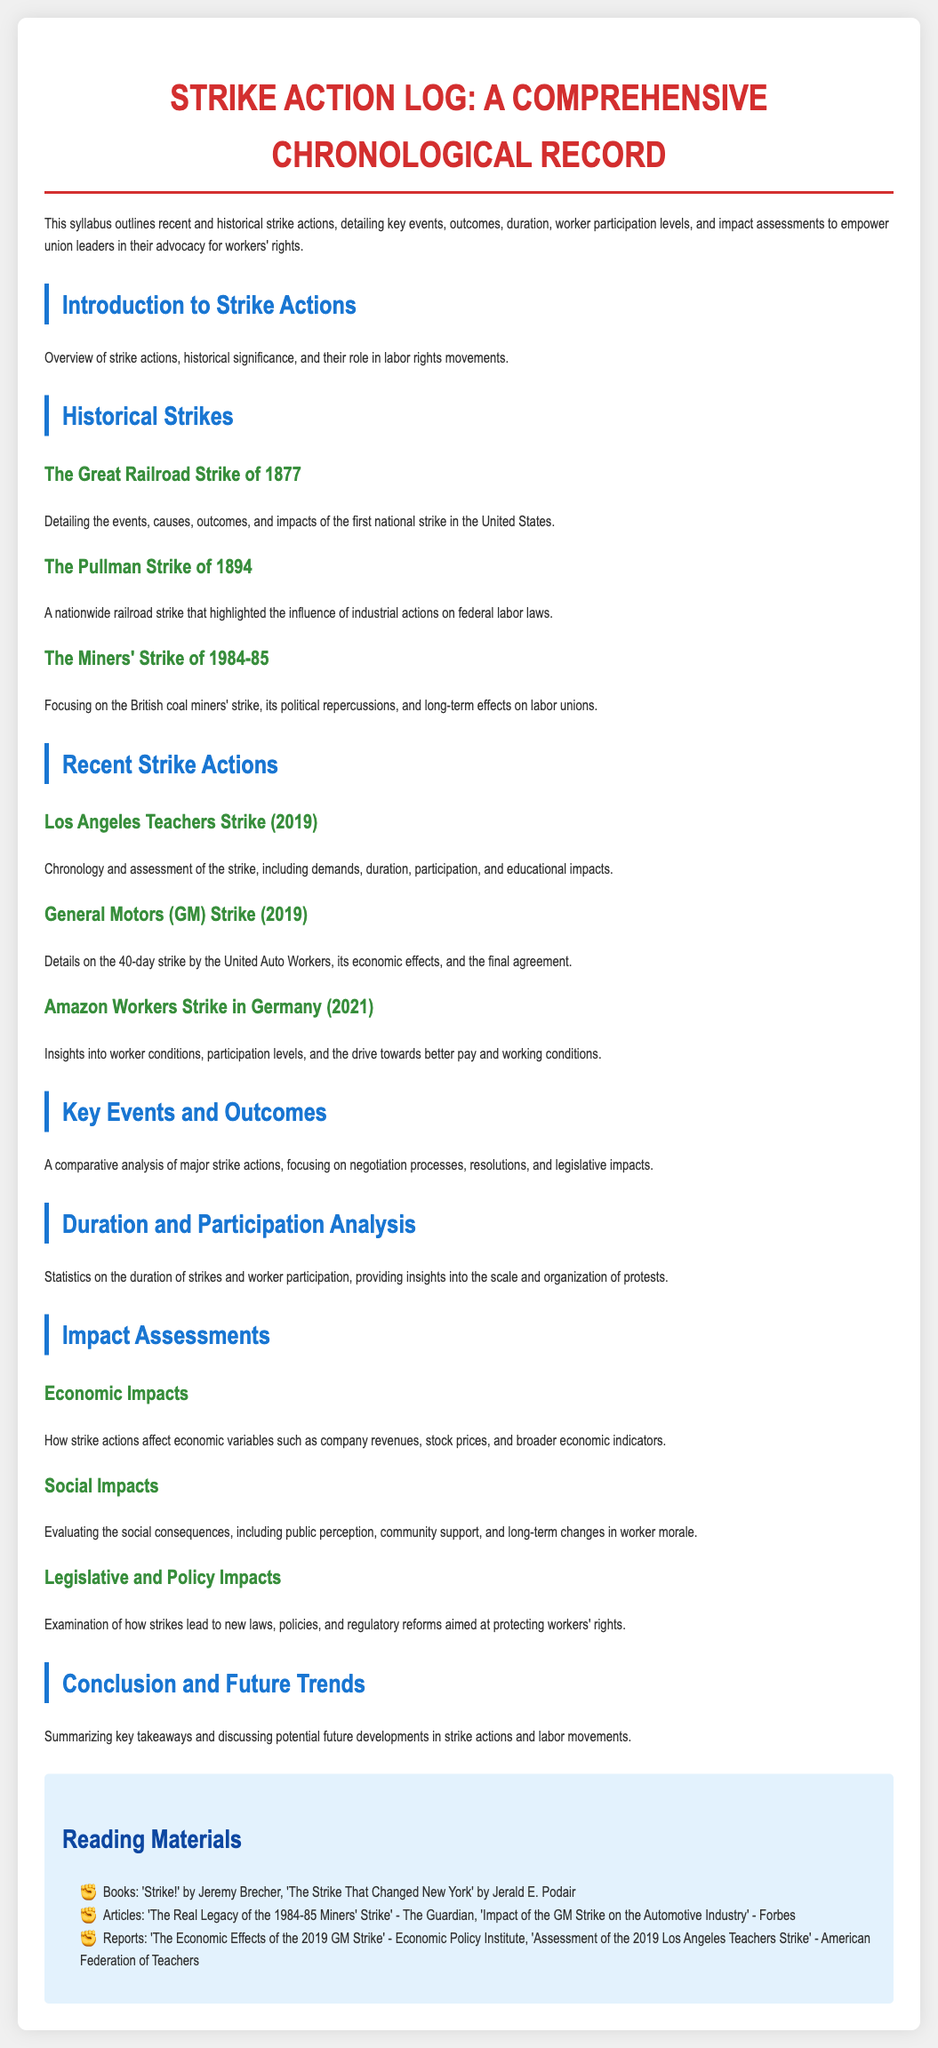What is the title of the document? The title is found at the top of the syllabus, summarizing its purpose.
Answer: Strike Action Log: A Comprehensive Chronological Record What year did the Los Angeles Teachers Strike take place? The document specifies the year of this recent strike directly in the section header.
Answer: 2019 Which historical strike is known as the first national strike in the United States? The document provides details about this significant strike in the historical context section.
Answer: The Great Railroad Strike of 1877 How many days did the General Motors strike last? The duration and specifics of this strike are detailed in the recent strike actions section.
Answer: 40 days What impact is discussed under the Economic Impacts section? The document outlines various effects that strikes have, particularly in this section.
Answer: Economic variables What is a key feature of the preparation for the future of labor movements? The conclusion of the document emphasizes upcoming trends and considerations based on past actions.
Answer: Future developments Which reading material is authored by Jeremy Brecher? The document lists books and articles related to strike actions in the reading materials section.
Answer: Strike! How does the document categorize the impacts of strikes? The impact assessments section is divided into specific categories for organization.
Answer: Economic, Social, Legislative What is the main purpose of the syllabus? The introduction of the syllabus explains its intent to educate and empower union leaders.
Answer: Empower union leaders 